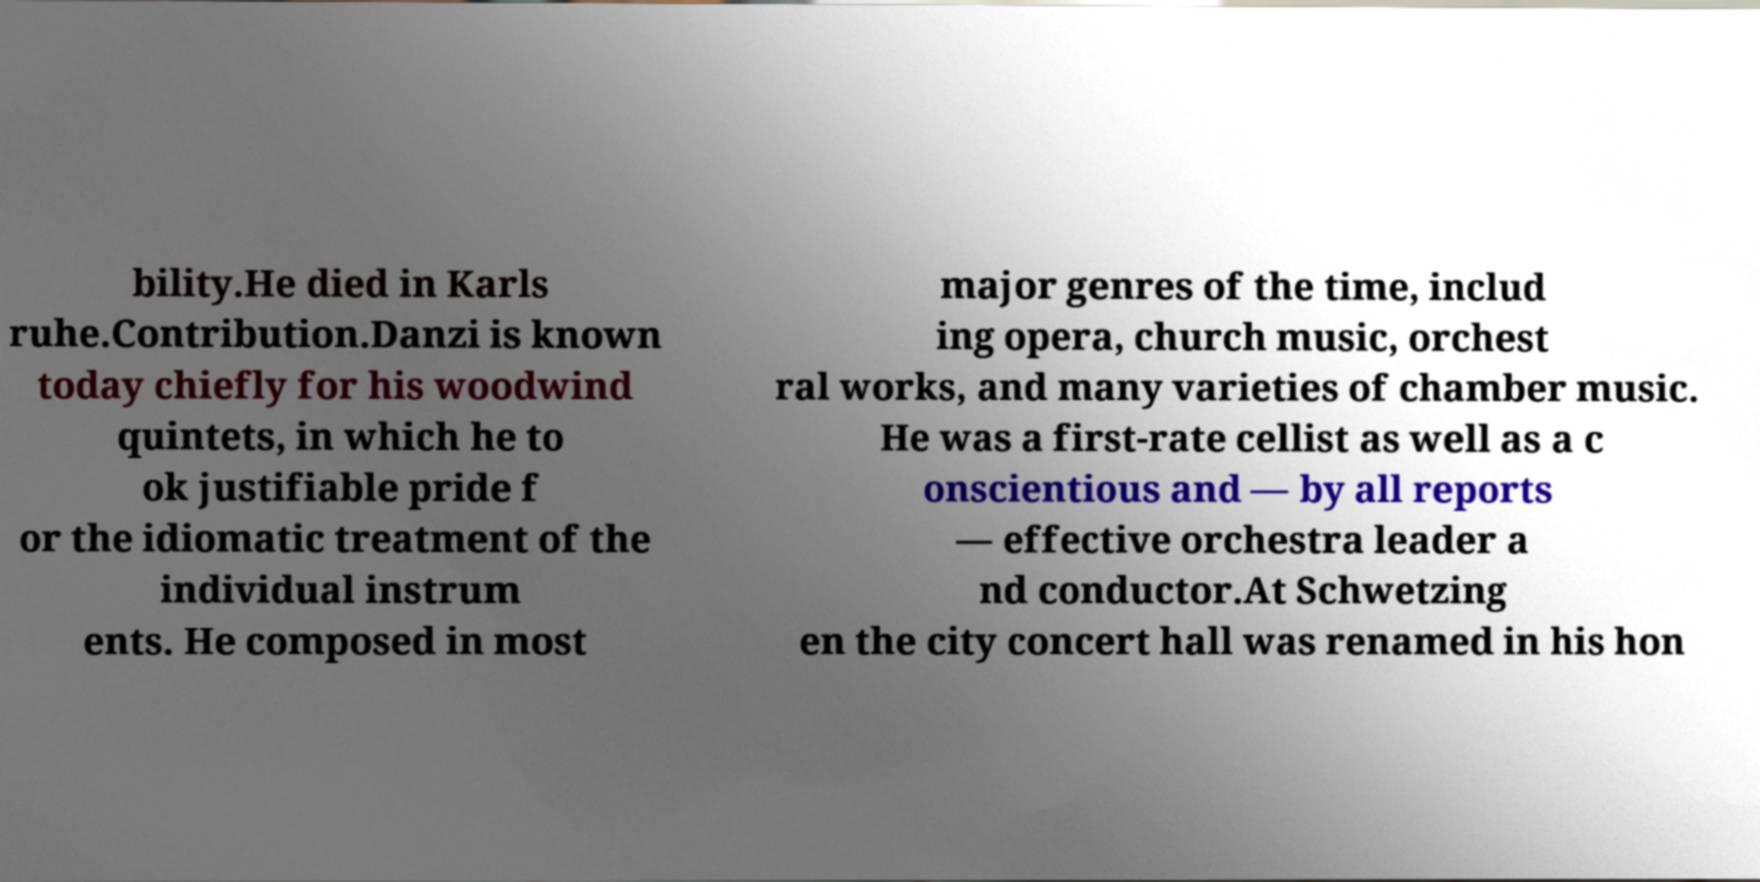What messages or text are displayed in this image? I need them in a readable, typed format. bility.He died in Karls ruhe.Contribution.Danzi is known today chiefly for his woodwind quintets, in which he to ok justifiable pride f or the idiomatic treatment of the individual instrum ents. He composed in most major genres of the time, includ ing opera, church music, orchest ral works, and many varieties of chamber music. He was a first-rate cellist as well as a c onscientious and — by all reports — effective orchestra leader a nd conductor.At Schwetzing en the city concert hall was renamed in his hon 